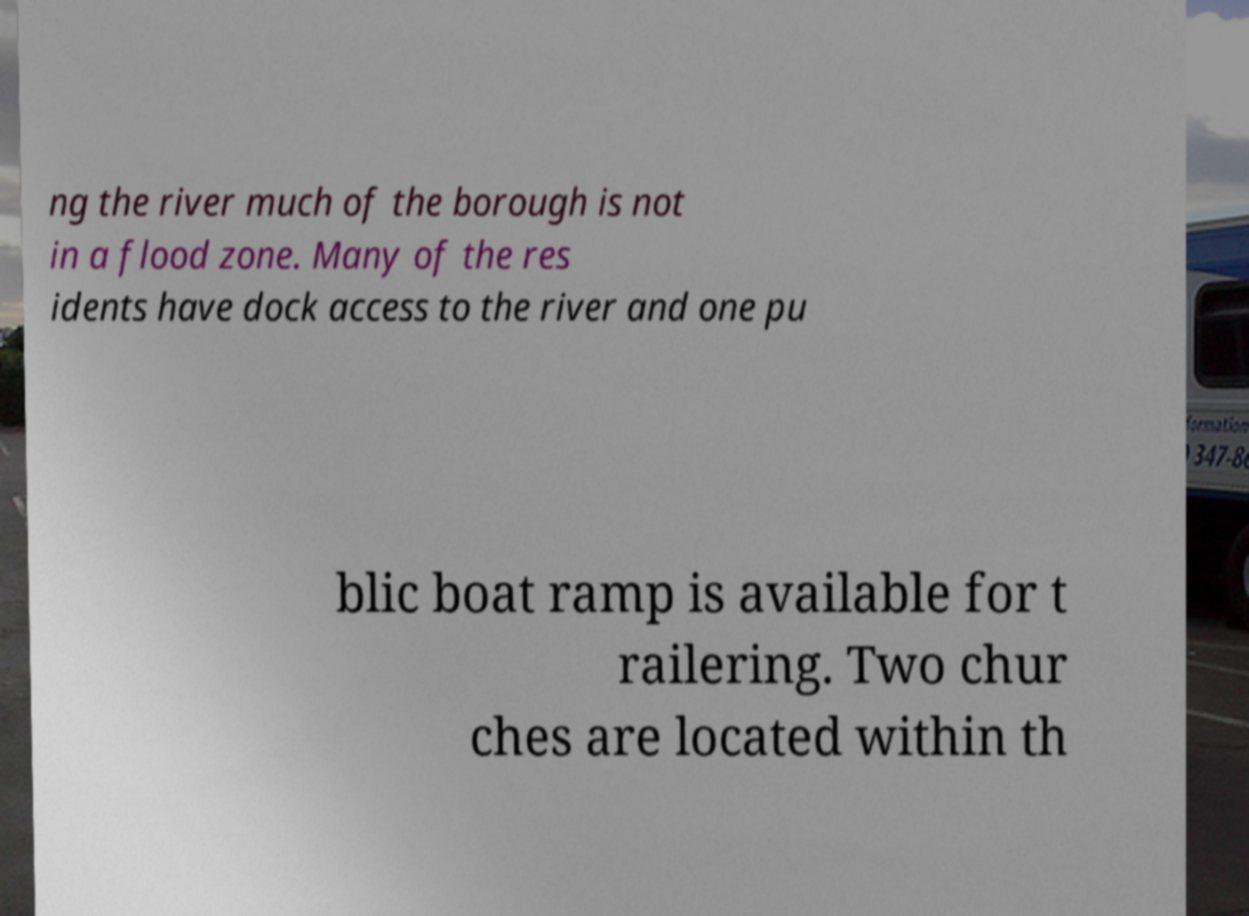Please read and relay the text visible in this image. What does it say? ng the river much of the borough is not in a flood zone. Many of the res idents have dock access to the river and one pu blic boat ramp is available for t railering. Two chur ches are located within th 